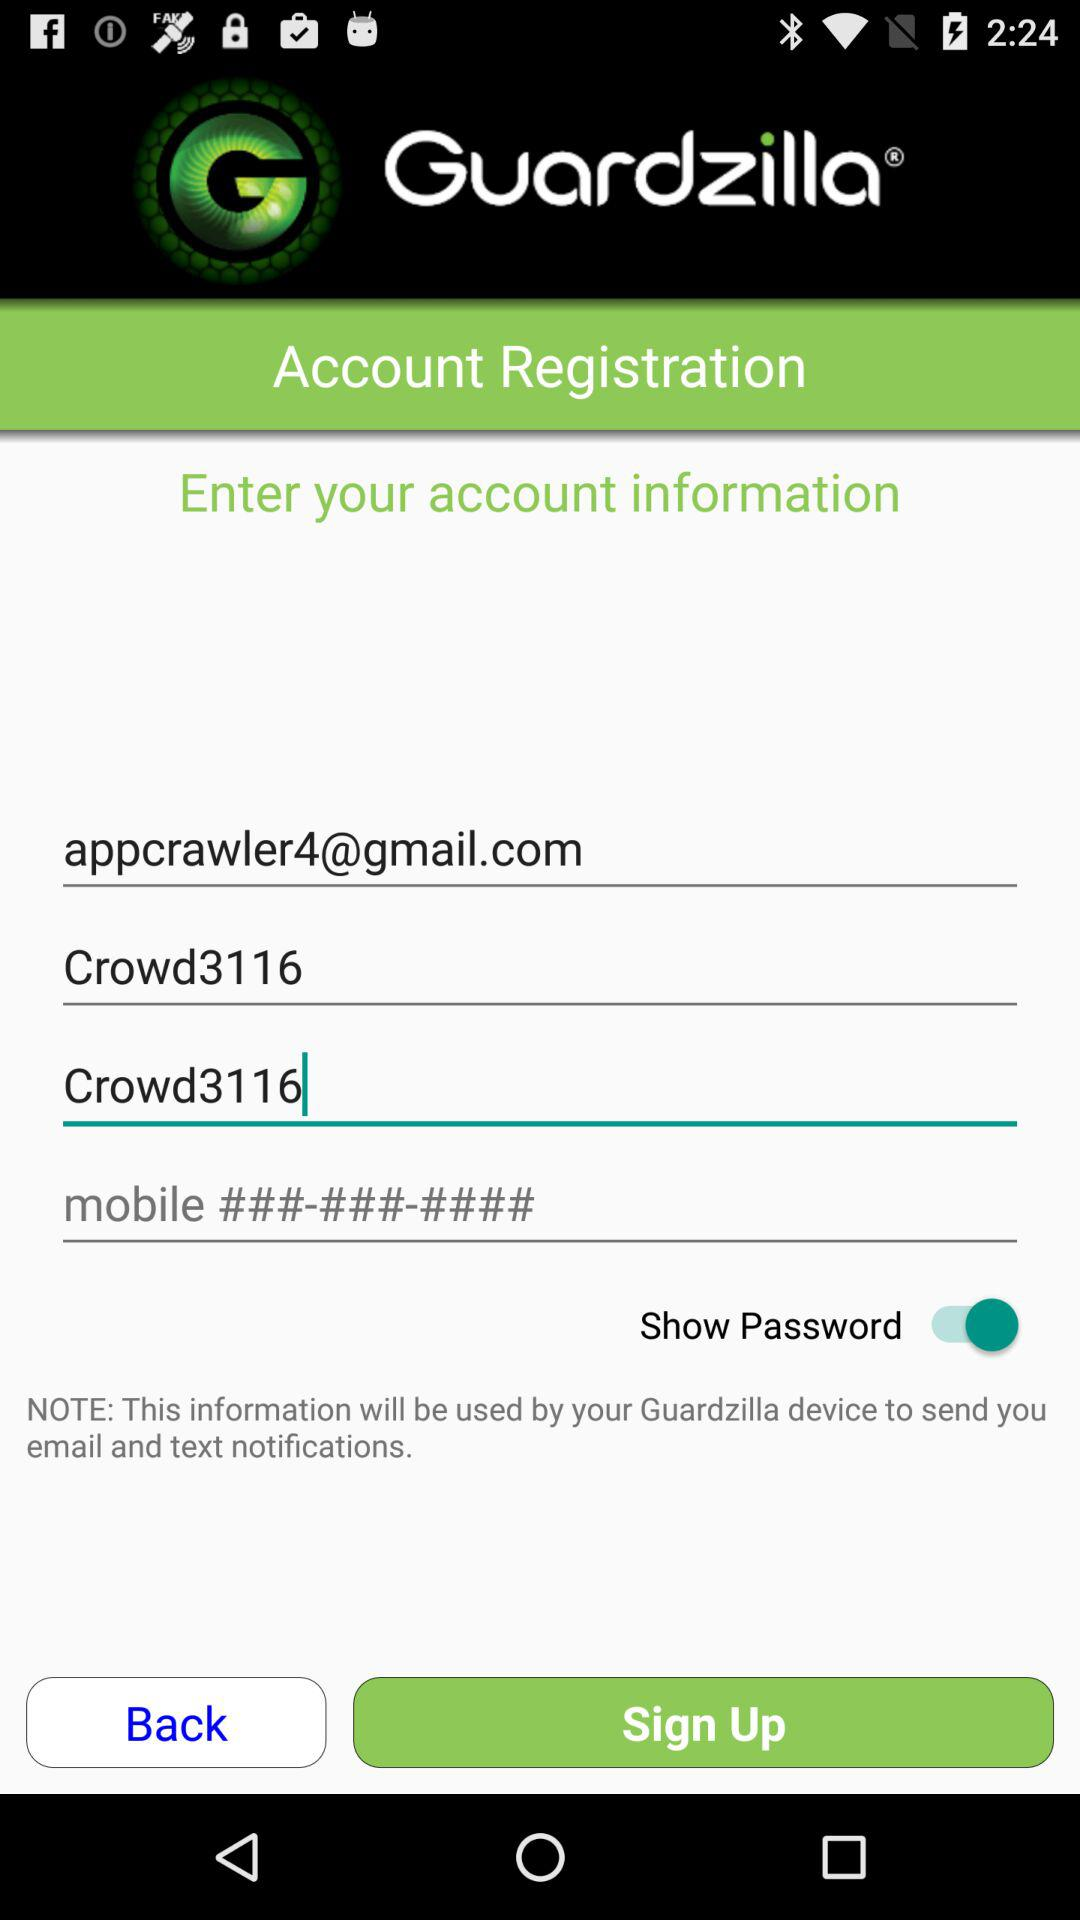What is the name of application? The name of the application is "Guardzilla®". 